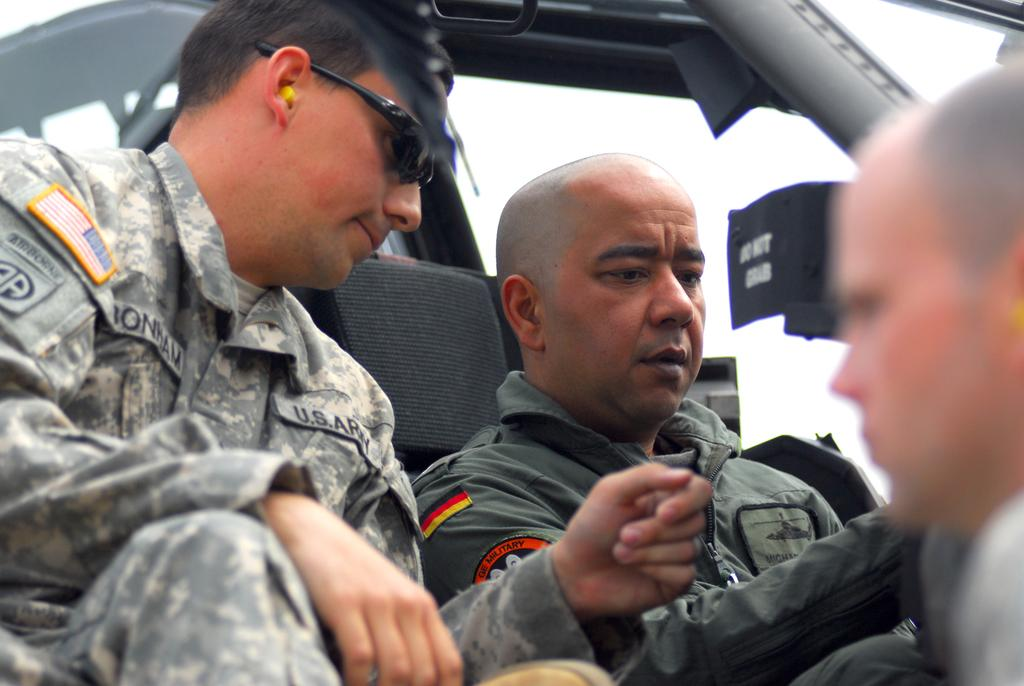How many people are in the vehicle in the image? There are two men in a vehicle in the image. What type of clothing are the men wearing? The men are wearing army uniforms. What can be seen on the right side of the image? There is a person's face on the right side of the image. How clear is the image of the person's face? The person's face is blurred. What type of blade is being used to tell a joke in the image? There is no blade or joke present in the image. What time is displayed on the clock in the image? There is no clock present in the image. 